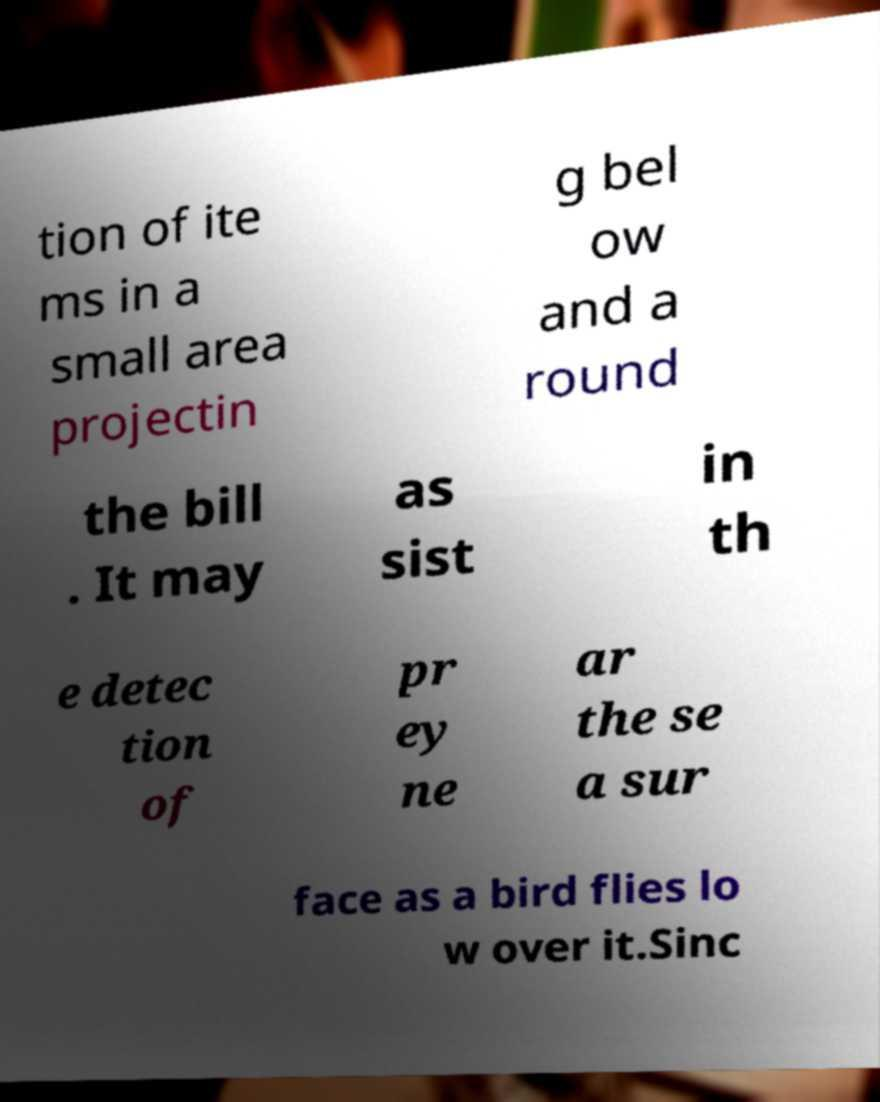What messages or text are displayed in this image? I need them in a readable, typed format. tion of ite ms in a small area projectin g bel ow and a round the bill . It may as sist in th e detec tion of pr ey ne ar the se a sur face as a bird flies lo w over it.Sinc 